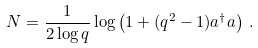Convert formula to latex. <formula><loc_0><loc_0><loc_500><loc_500>N = \frac { 1 } { 2 \log q } \log \left ( 1 + ( q ^ { 2 } - 1 ) a ^ { \dag } a \right ) \, .</formula> 